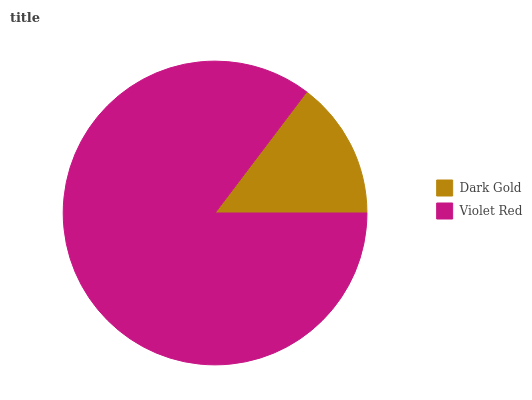Is Dark Gold the minimum?
Answer yes or no. Yes. Is Violet Red the maximum?
Answer yes or no. Yes. Is Violet Red the minimum?
Answer yes or no. No. Is Violet Red greater than Dark Gold?
Answer yes or no. Yes. Is Dark Gold less than Violet Red?
Answer yes or no. Yes. Is Dark Gold greater than Violet Red?
Answer yes or no. No. Is Violet Red less than Dark Gold?
Answer yes or no. No. Is Violet Red the high median?
Answer yes or no. Yes. Is Dark Gold the low median?
Answer yes or no. Yes. Is Dark Gold the high median?
Answer yes or no. No. Is Violet Red the low median?
Answer yes or no. No. 